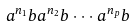<formula> <loc_0><loc_0><loc_500><loc_500>a ^ { n _ { 1 } } b a ^ { n _ { 2 } } b \cdot \cdot \cdot a ^ { n _ { p } } b</formula> 